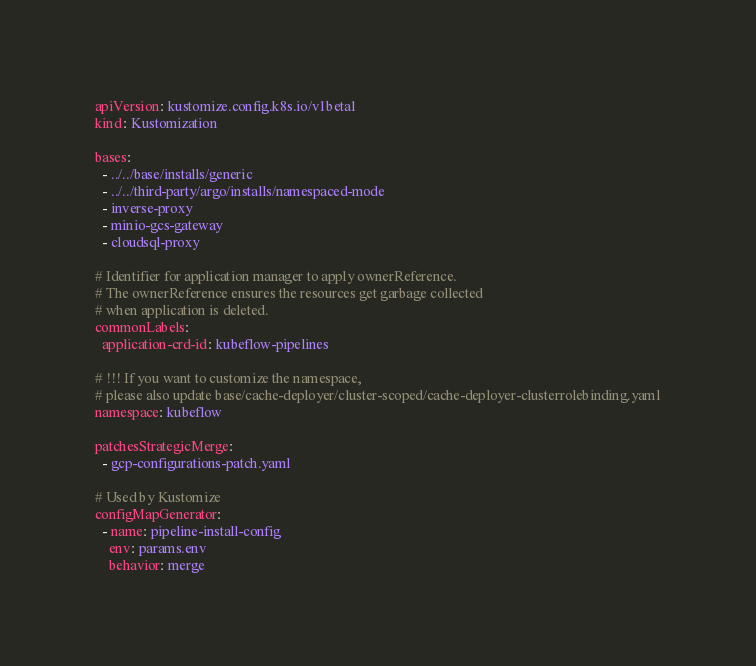<code> <loc_0><loc_0><loc_500><loc_500><_YAML_>apiVersion: kustomize.config.k8s.io/v1beta1
kind: Kustomization

bases:
  - ../../base/installs/generic
  - ../../third-party/argo/installs/namespaced-mode
  - inverse-proxy
  - minio-gcs-gateway
  - cloudsql-proxy

# Identifier for application manager to apply ownerReference.
# The ownerReference ensures the resources get garbage collected
# when application is deleted.
commonLabels:
  application-crd-id: kubeflow-pipelines

# !!! If you want to customize the namespace,
# please also update base/cache-deployer/cluster-scoped/cache-deployer-clusterrolebinding.yaml
namespace: kubeflow

patchesStrategicMerge:
  - gcp-configurations-patch.yaml

# Used by Kustomize
configMapGenerator:
  - name: pipeline-install-config
    env: params.env
    behavior: merge
</code> 